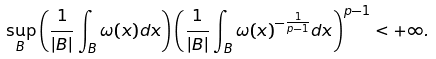Convert formula to latex. <formula><loc_0><loc_0><loc_500><loc_500>\underset { B } { \sup } \left ( \frac { 1 } { | B | } \int _ { B } \omega ( x ) d x \right ) \left ( \frac { 1 } { | B | } \int _ { B } \omega ( x ) ^ { - \frac { 1 } { p - 1 } } d x \right ) ^ { p - 1 } < + \infty .</formula> 